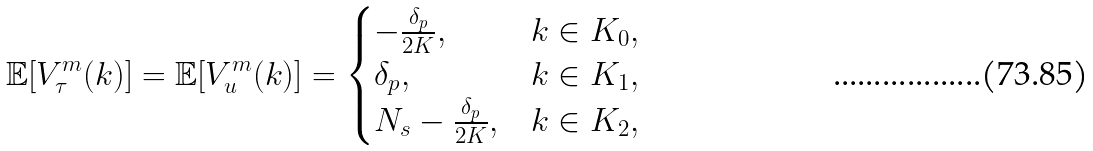<formula> <loc_0><loc_0><loc_500><loc_500>\mathbb { E } [ V _ { \tau } ^ { m } ( k ) ] = \mathbb { E } [ V _ { u } ^ { m } ( k ) ] = \begin{cases} - \frac { \delta _ { p } } { 2 K } , & k \in K _ { 0 } , \\ \delta _ { p } , & k \in K _ { 1 } , \\ N _ { s } - \frac { \delta _ { p } } { 2 K } , & k \in K _ { 2 } , \end{cases}</formula> 